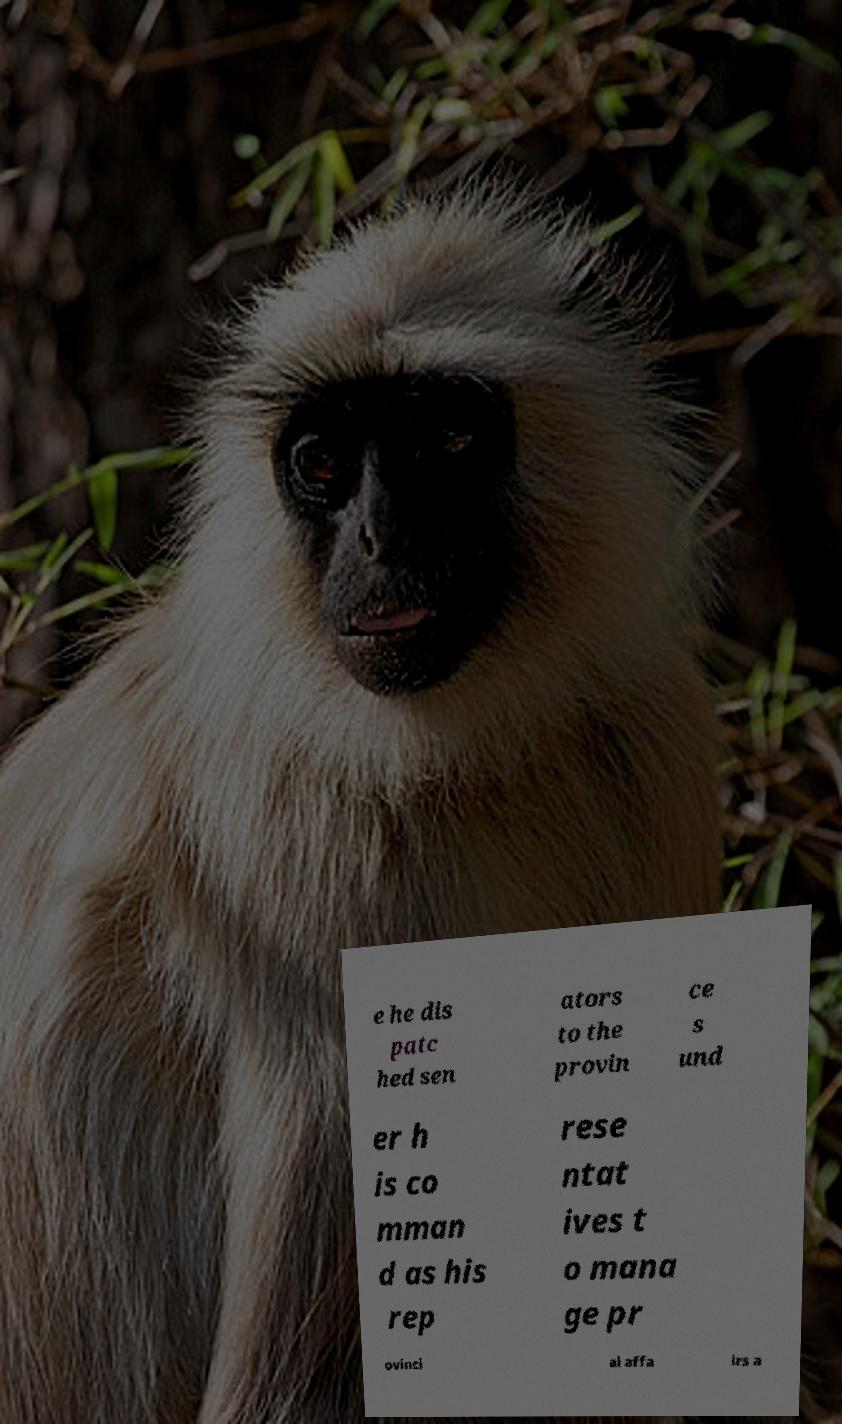Could you assist in decoding the text presented in this image and type it out clearly? e he dis patc hed sen ators to the provin ce s und er h is co mman d as his rep rese ntat ives t o mana ge pr ovinci al affa irs a 